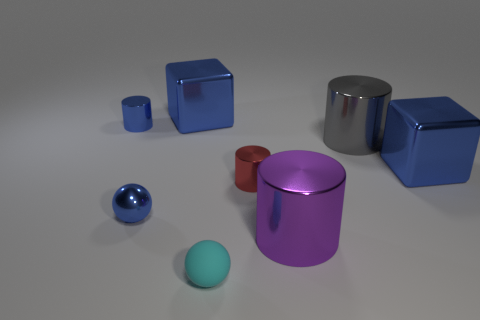How many tiny metal objects are to the left of the big metallic block in front of the big gray shiny thing?
Offer a very short reply. 3. How many other objects are the same material as the cyan thing?
Ensure brevity in your answer.  0. Is the material of the blue block on the right side of the large purple cylinder the same as the tiny object behind the tiny red object?
Your response must be concise. Yes. Is the tiny red cylinder made of the same material as the blue thing that is to the left of the small metal ball?
Offer a terse response. Yes. What color is the sphere that is right of the blue thing that is in front of the object that is right of the gray thing?
Provide a short and direct response. Cyan. There is a purple metal thing that is the same size as the gray metal cylinder; what is its shape?
Offer a terse response. Cylinder. There is a blue thing that is to the right of the cyan rubber thing; is it the same size as the blue metal block to the left of the small cyan sphere?
Ensure brevity in your answer.  Yes. There is a shiny cube right of the gray shiny object; what is its size?
Offer a very short reply. Large. There is a cylinder that is the same color as the metallic ball; what material is it?
Provide a short and direct response. Metal. The metal ball that is the same size as the red metallic cylinder is what color?
Your answer should be very brief. Blue. 